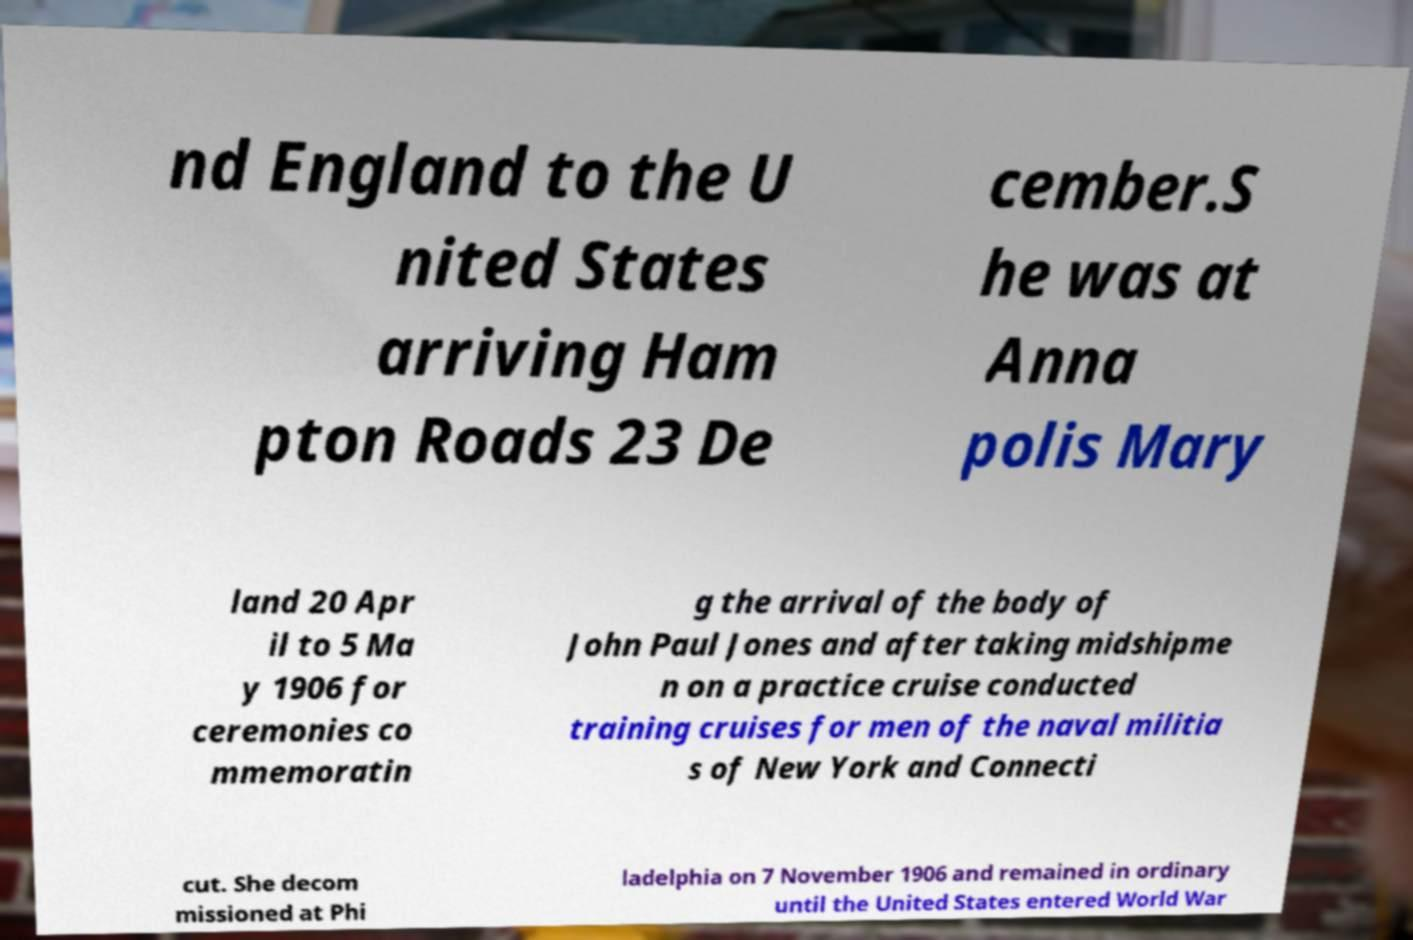Please identify and transcribe the text found in this image. nd England to the U nited States arriving Ham pton Roads 23 De cember.S he was at Anna polis Mary land 20 Apr il to 5 Ma y 1906 for ceremonies co mmemoratin g the arrival of the body of John Paul Jones and after taking midshipme n on a practice cruise conducted training cruises for men of the naval militia s of New York and Connecti cut. She decom missioned at Phi ladelphia on 7 November 1906 and remained in ordinary until the United States entered World War 